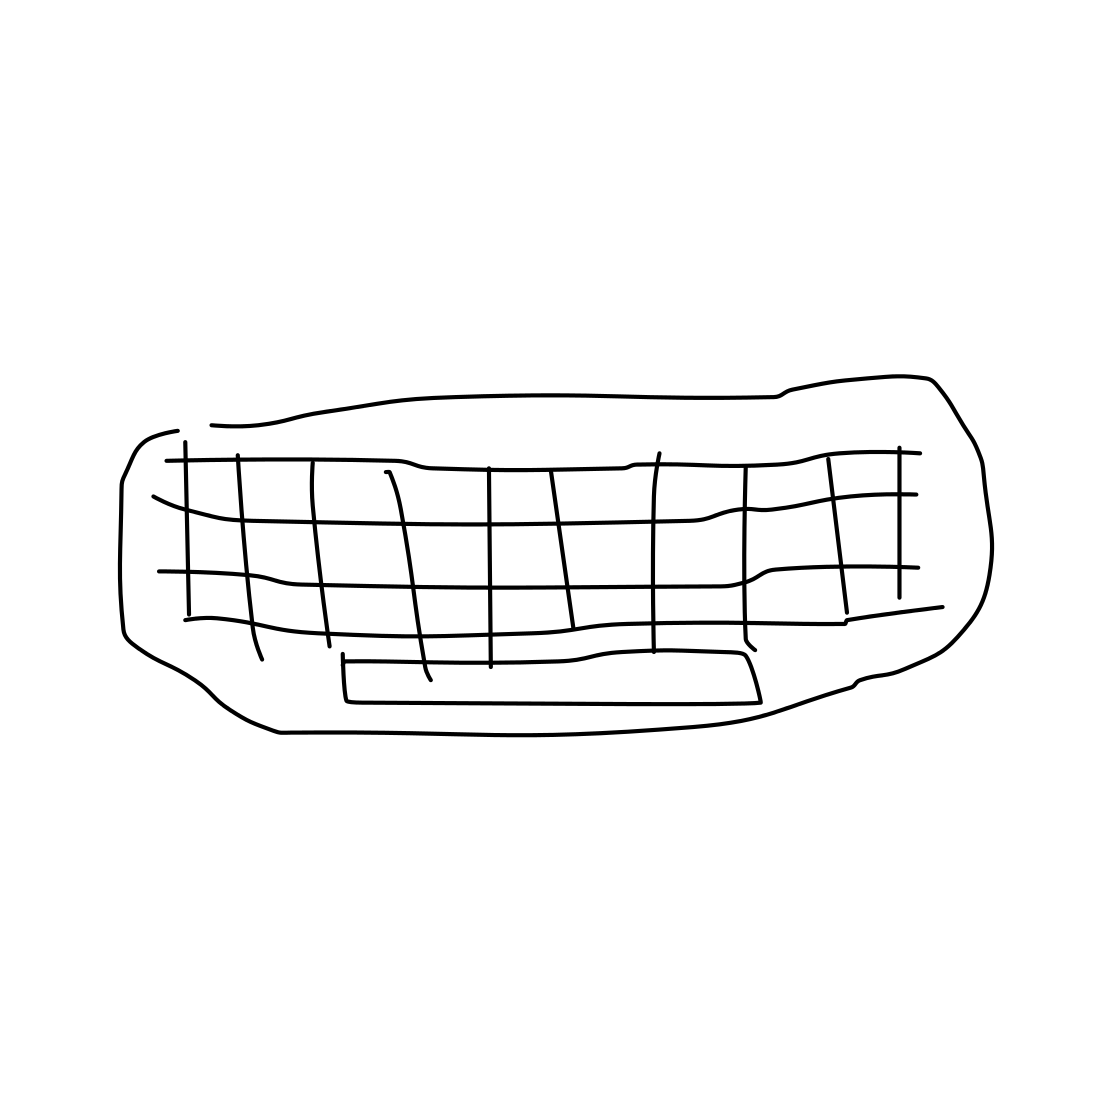What kind of furniture is depicted in this image? The image shows a simplistic line drawing of a couch. 